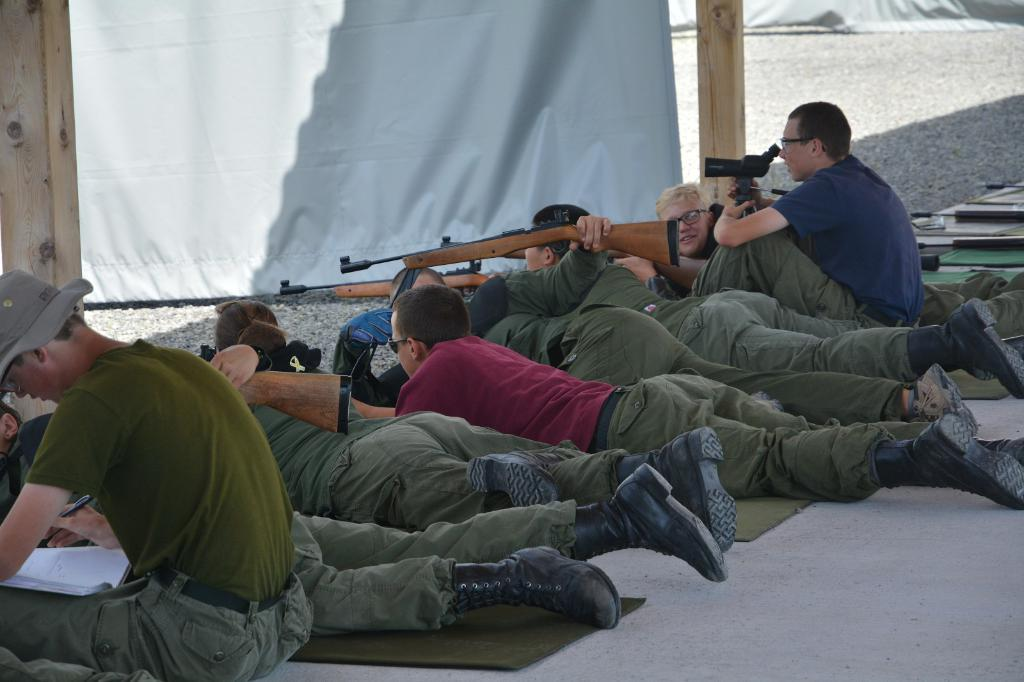How many people are sitting in the center of the image? There are two persons sitting in the center of the image. What are the people in the image doing besides sitting? There are people lying down and holding objects in the image. What can be seen in the background of the image? There are curtains and poles visible in the background of the image. How much dirt can be seen on the floor in the image? There is no dirt visible on the floor in the image. Are there any giants present in the image? There are no giants present in the image. 